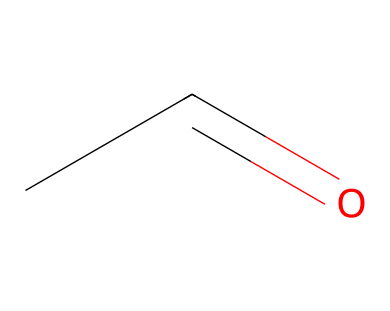What is the name of this chemical? The given SMILES representation "CC=O" corresponds to the chemical structure of acetaldehyde, which is an aldehyde due to the presence of the carbonyl group at the end of the carbon chain.
Answer: acetaldehyde How many carbon atoms are in this molecule? The SMILES "CC=O" indicates there are two carbon atoms, as represented by the two 'C' symbols before the carbonyl group.
Answer: 2 What functional group is present in acetaldehyde? The carbonyl group (C=O) is indicated in the SMILES notation "CC=O," characterizing it as an aldehyde. Specifically, it is the carbonyl attached to a hydrogen atom (aldehyde) that defines its functional group.
Answer: carbonyl What is the total number of hydrogen atoms in this molecule? In the structure represented by "CC=O," each carbon in carbon chains typically bonds with enough hydrogen atoms to satisfy carbon's tetravalent requirement. The first carbon has three hydrogens, and the second carbon has one hydrogen (because it's bonded to the oxygen), totaling four hydrogen atoms.
Answer: 4 Is acetaldehyde a volatile compound? Acetaldehyde, due to its low molecular weight and structure, is volatile, which means it readily evaporates and has a low boiling point compared to heavier substances. Thus, it can easily become a gas at room temperature.
Answer: yes How does the arrangement of atoms affect the reactivity of acetaldehyde? The carbonyl group (C=O) in acetaldehyde makes it highly reactive due to its partial positive charge on carbon, which can easily undergo nucleophilic attack. This arrangement influences its role in various chemical reactions including polymerization in adhesives.
Answer: high reactivity What type of reaction is acetaldehyde commonly involved in when used in adhesives? Acetaldehyde is typically involved in condensation reactions or polymerization when utilized in adhesives, reacting with other monomers to form larger polymeric structures essential for adhesive properties.
Answer: polymerization 